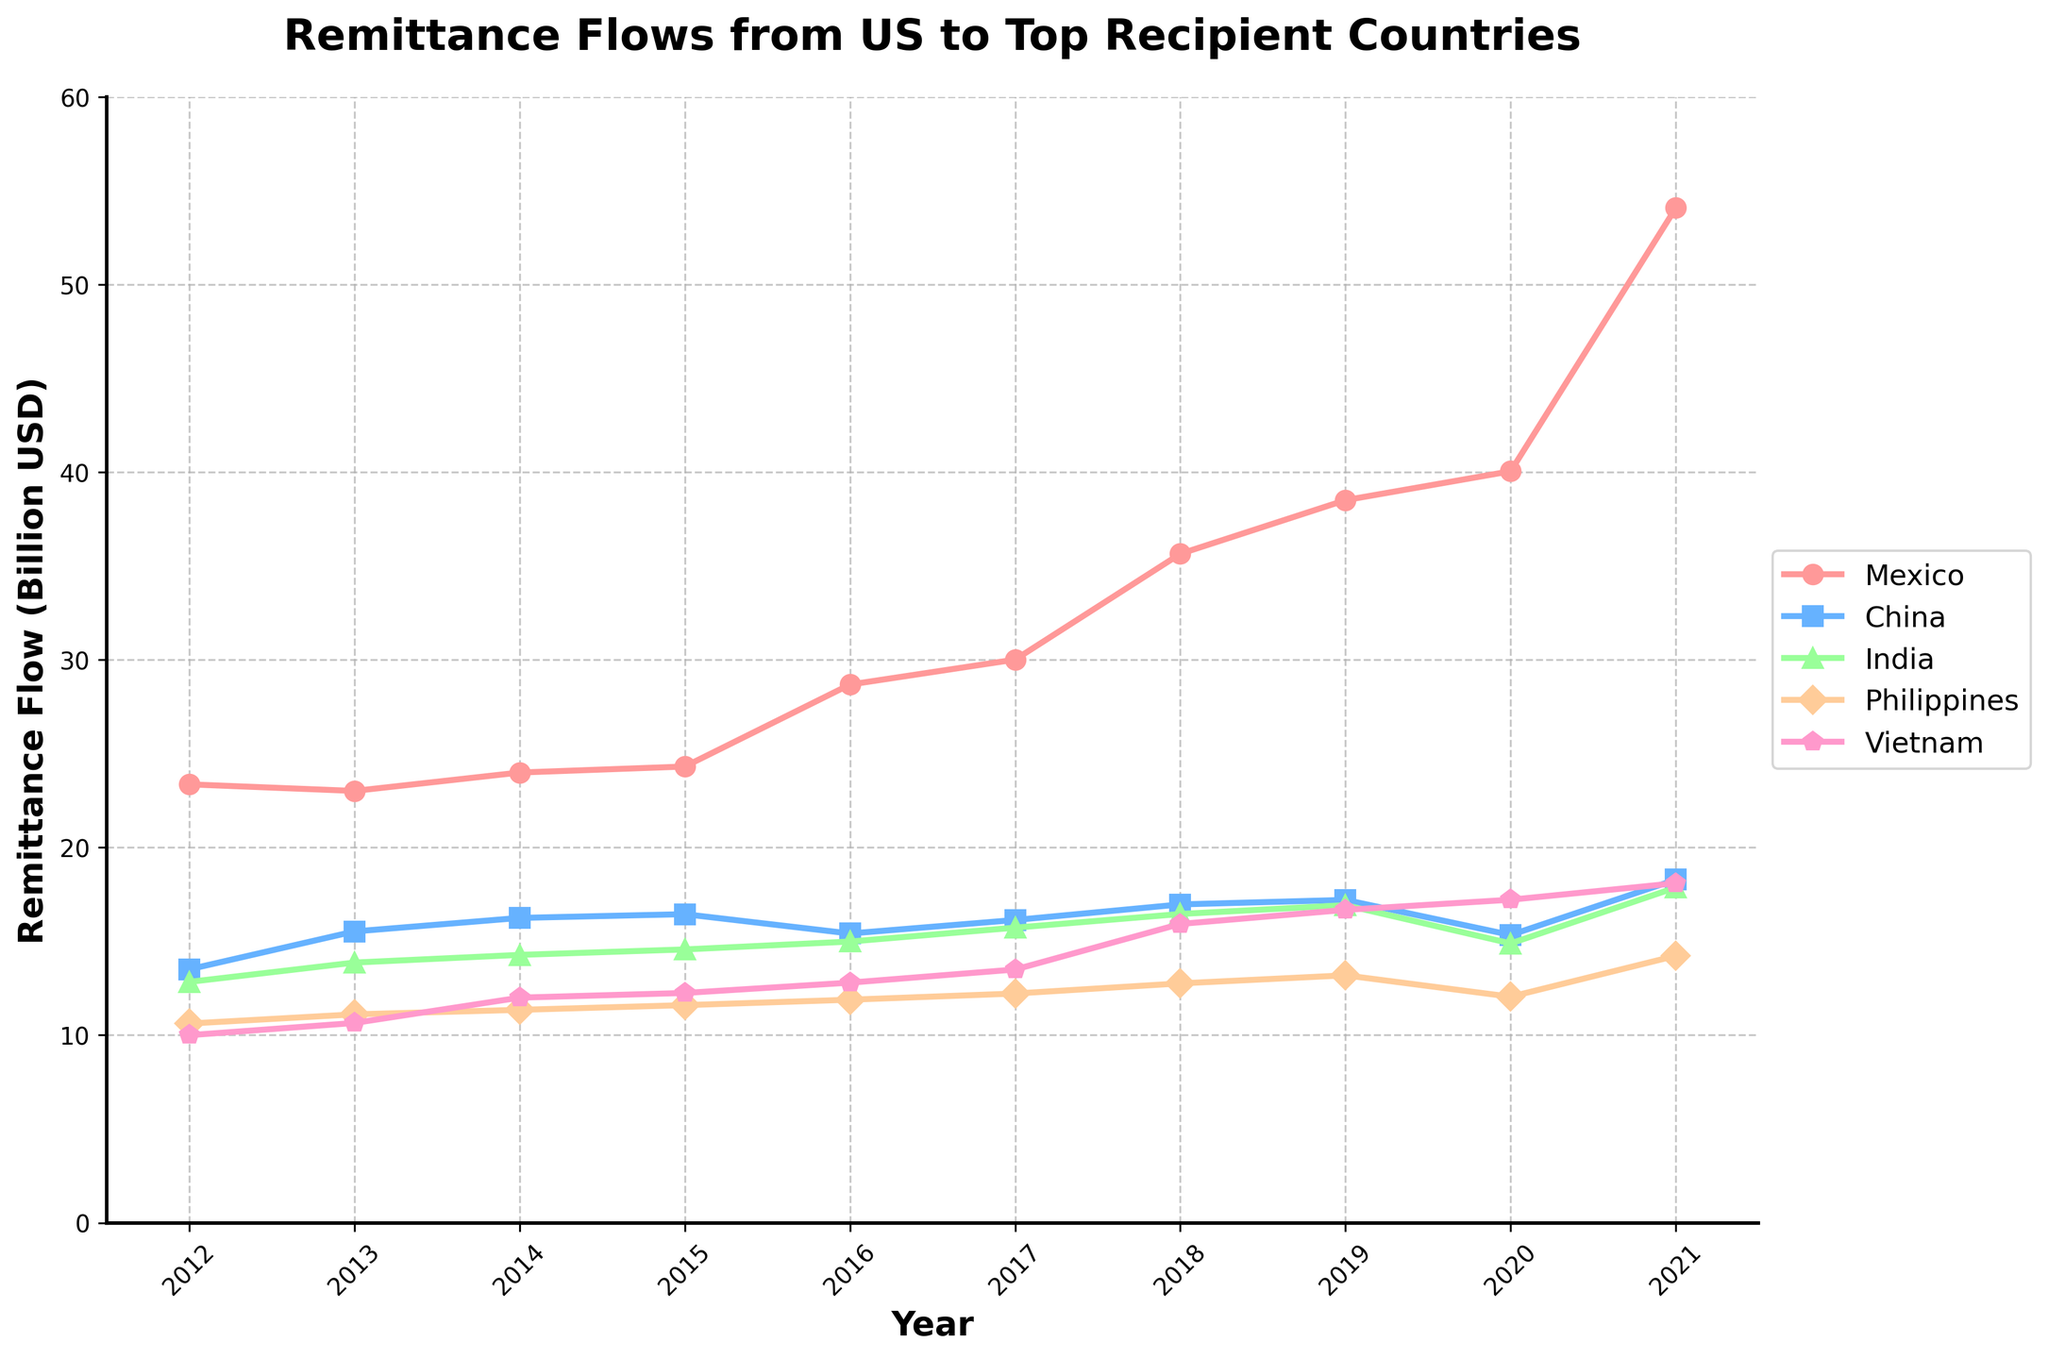What was the overall trend in remittance flows to Mexico from 2012 to 2021? Observe the line representing Mexico. It starts at approximately 23.37 billion USD in 2012 and ends at 54.10 billion USD in 2021, showing a general increasing trend over the decade.
Answer: Increasing trend Which country received the highest remittance in 2017? Compare the remittance values for all countries in 2017. Mexico received the highest remittance flow, which is 30.02 billion USD.
Answer: Mexico How did remittance flows to China change from 2019 to 2020? Look at the remittance values for China in 2019 and 2020. In 2019, it was 17.21 billion USD and it decreased to 15.34 billion USD in 2020.
Answer: Decreased What was the difference between the remittance flows to India and the Philippines in 2021? Compare the remittance values for India and the Philippines in 2021: India had 17.87 billion USD, and the Philippines had 14.23 billion USD. The difference is 17.87 - 14.23 = 3.64 billion USD.
Answer: 3.64 billion USD Which year shows the highest remittance flow to Vietnam? Track the line representing Vietnam over the years and identify the peak value. The highest remittance flow to Vietnam was in 2021, at 18.10 billion USD.
Answer: 2021 What color represents the remittance flow to India in the plot? Look at the legend to find the corresponding color for India. The color representing India's remittance flow is green.
Answer: Green By how much did remittance flows to the Philippines increase from 2012 to 2021? Compare the remittance values for the Philippines in 2012 and 2021. In 2012, it was 10.62 billion USD, and in 2021, it was 14.23 billion USD. The increase is 14.23 - 10.62 = 3.61 billion USD.
Answer: 3.61 billion USD How did the remittance flow to Mexico compare to the remittance flow to India in 2018? Compare the values for Mexico and India in 2018. Mexico received 35.66 billion USD, while India received 16.46 billion USD. Mexico's remittance flow was more than twice that of India's.
Answer: More than twice 